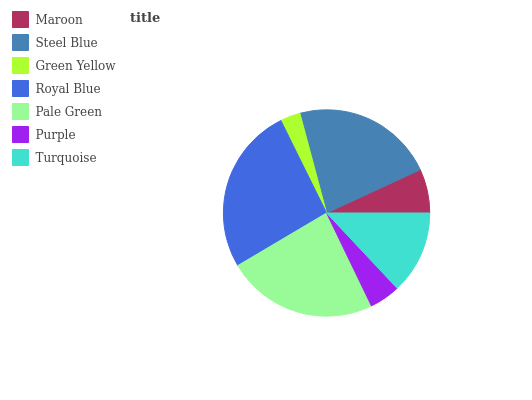Is Green Yellow the minimum?
Answer yes or no. Yes. Is Royal Blue the maximum?
Answer yes or no. Yes. Is Steel Blue the minimum?
Answer yes or no. No. Is Steel Blue the maximum?
Answer yes or no. No. Is Steel Blue greater than Maroon?
Answer yes or no. Yes. Is Maroon less than Steel Blue?
Answer yes or no. Yes. Is Maroon greater than Steel Blue?
Answer yes or no. No. Is Steel Blue less than Maroon?
Answer yes or no. No. Is Turquoise the high median?
Answer yes or no. Yes. Is Turquoise the low median?
Answer yes or no. Yes. Is Purple the high median?
Answer yes or no. No. Is Royal Blue the low median?
Answer yes or no. No. 